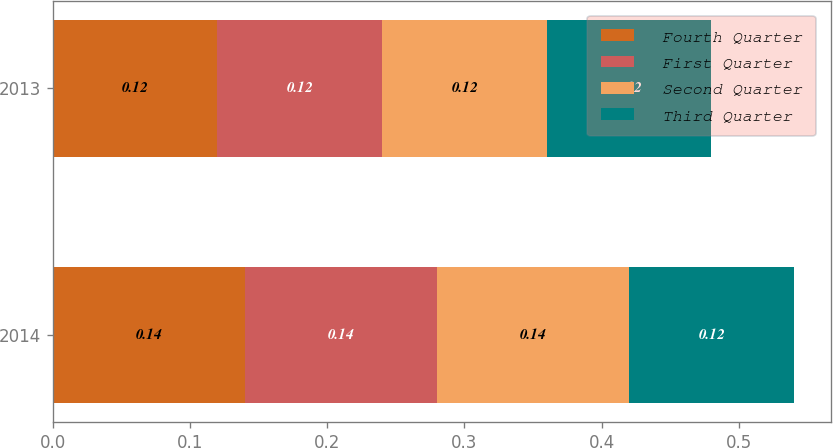Convert chart to OTSL. <chart><loc_0><loc_0><loc_500><loc_500><stacked_bar_chart><ecel><fcel>2014<fcel>2013<nl><fcel>Fourth Quarter<fcel>0.14<fcel>0.12<nl><fcel>First Quarter<fcel>0.14<fcel>0.12<nl><fcel>Second Quarter<fcel>0.14<fcel>0.12<nl><fcel>Third Quarter<fcel>0.12<fcel>0.12<nl></chart> 